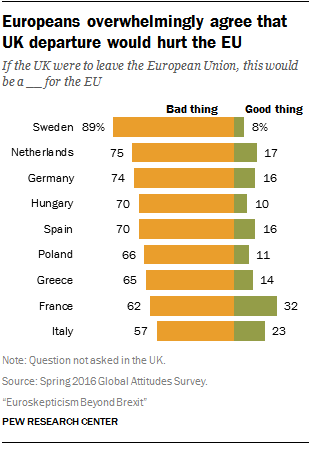List a handful of essential elements in this visual. A survey found that 16% of Germans believe that it is a good thing. According to a recent survey, in at least two countries over 20% of people believe that it is a positive development for society. 